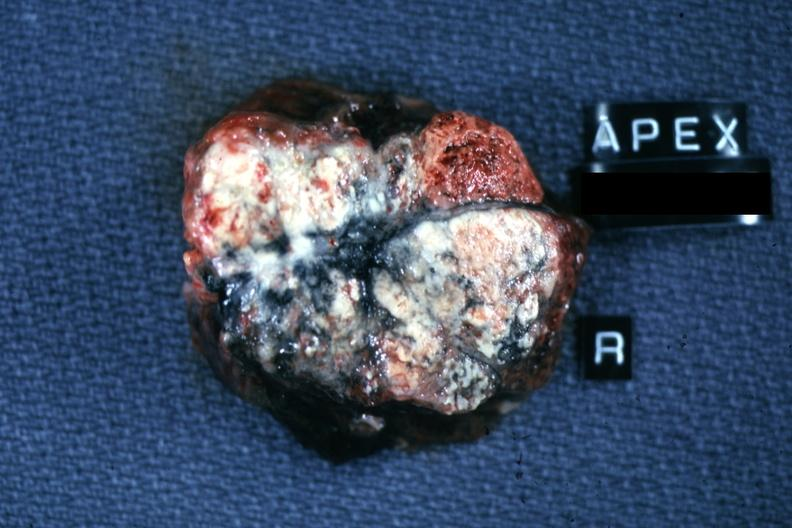s lymphangiomatosis generalized present?
Answer the question using a single word or phrase. No 